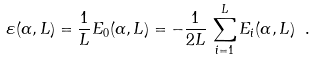Convert formula to latex. <formula><loc_0><loc_0><loc_500><loc_500>\varepsilon ( \alpha , L ) = \frac { 1 } { L } E _ { 0 } ( \alpha , L ) = - \frac { 1 } { 2 L } \, \sum _ { i = 1 } ^ { L } E _ { i } ( \alpha , L ) \ .</formula> 